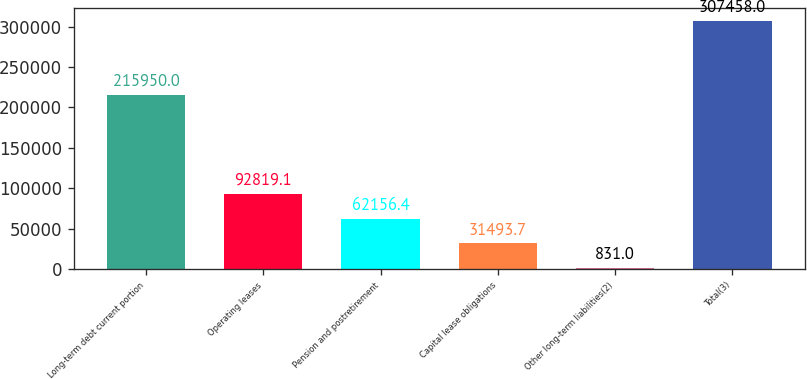Convert chart to OTSL. <chart><loc_0><loc_0><loc_500><loc_500><bar_chart><fcel>Long-term debt current portion<fcel>Operating leases<fcel>Pension and postretirement<fcel>Capital lease obligations<fcel>Other long-term liabilities(2)<fcel>Total(3)<nl><fcel>215950<fcel>92819.1<fcel>62156.4<fcel>31493.7<fcel>831<fcel>307458<nl></chart> 